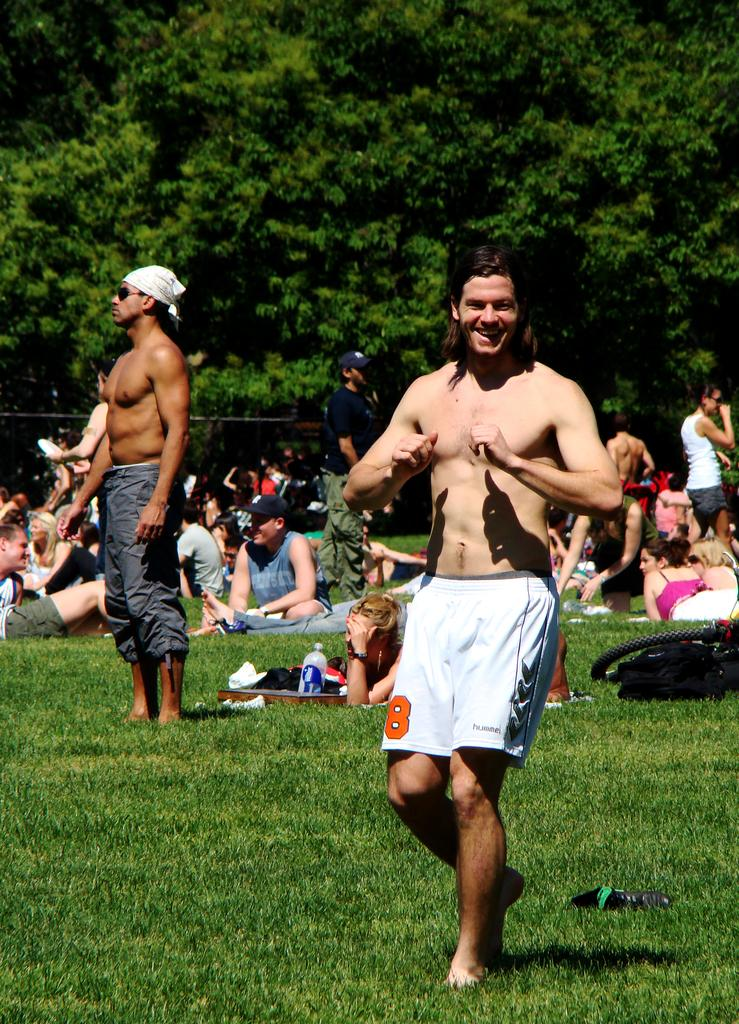<image>
Summarize the visual content of the image. a man in a crowded park with no shirt on and shorts with number 8 on them 